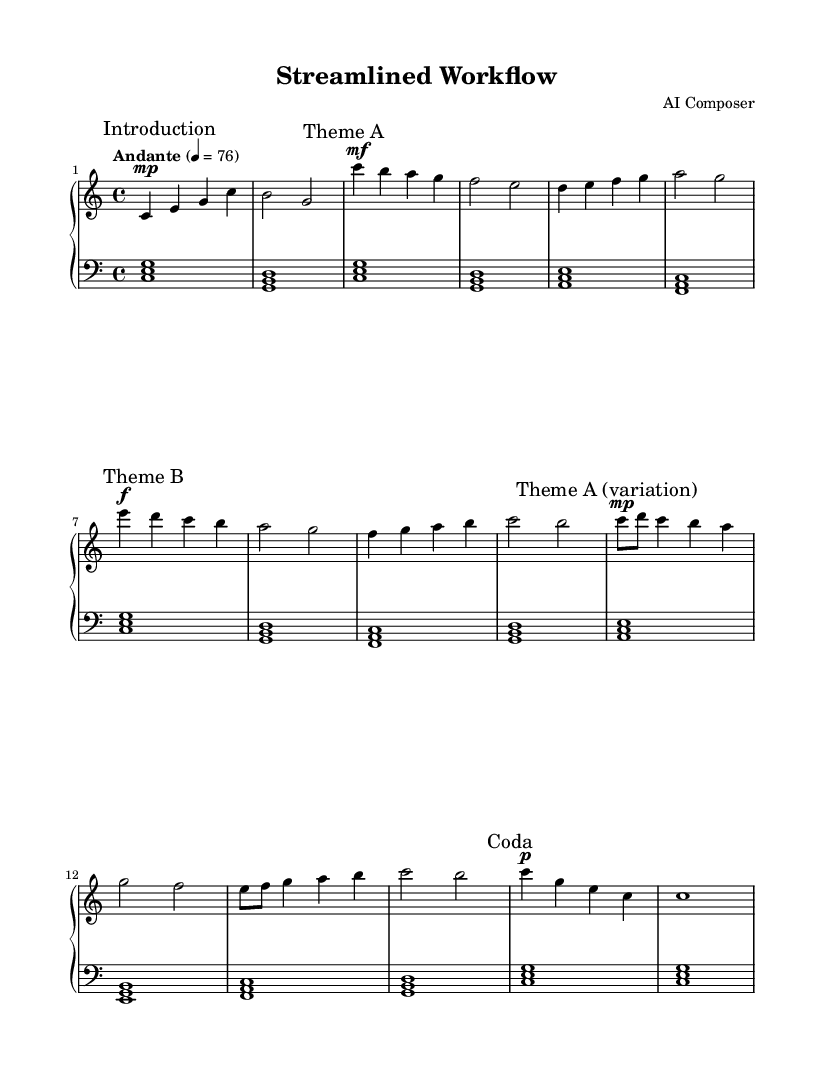What is the key signature of this music? The key signature is C major, which has no sharps or flats.
Answer: C major What is the time signature of this music? The time signature is indicated as 4/4, meaning there are four beats in a measure.
Answer: 4/4 What is the tempo marking for this piece? The tempo marking is "Andante," which indicates a moderate pace.
Answer: Andante How many distinct themes are present in the composition? The composition includes two distinct themes (Theme A and Theme B) and a variation of Theme A.
Answer: Three What is the dynamic marking for Theme B? The dynamic marking for Theme B is forte, indicated by the symbol "f".
Answer: forte What are the first three notes in the introduction? The first three notes of the introduction are C, E, and G, forming a C major chord.
Answer: C E G Which section follows Theme B in the structure? The section that follows Theme B is the variation of Theme A. This can be seen as the structure continues logically after presenting Theme B.
Answer: Theme A (variation) 